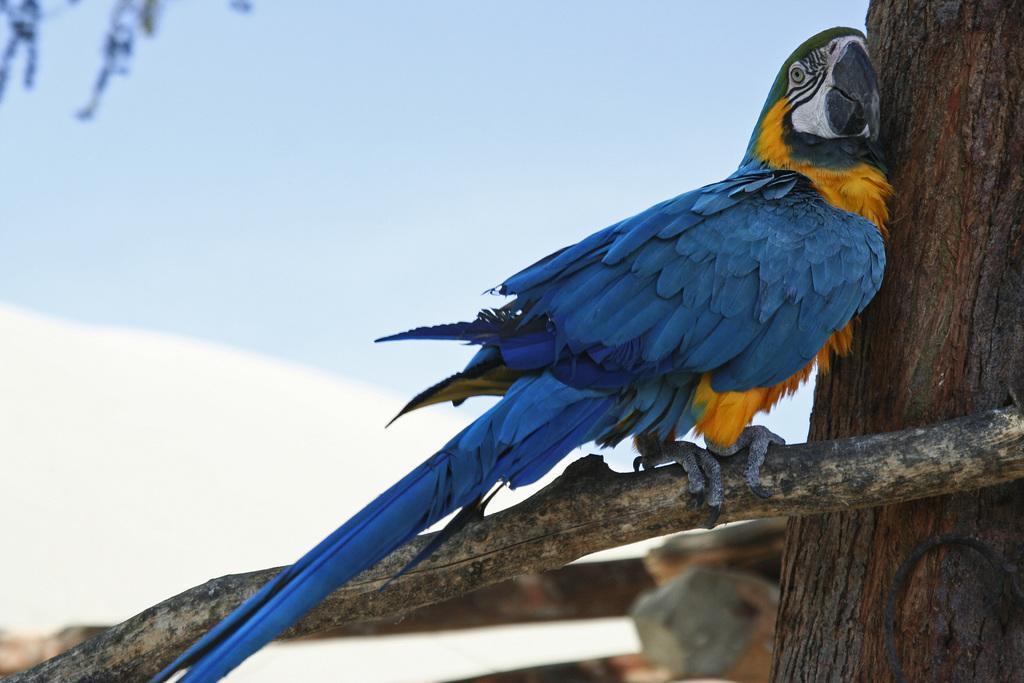How would you summarize this image in a sentence or two? In the foreground I can see a parrot is sitting on the branch of a tree and a tree trunk. In the background I can see the sky. This image is taken during a day. 